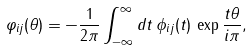<formula> <loc_0><loc_0><loc_500><loc_500>\varphi _ { i j } ( \theta ) = - \frac { 1 } { 2 \pi } \int _ { - \infty } ^ { \infty } d t \, \phi _ { i j } ( t ) \, \exp \frac { t \theta } { i \pi } ,</formula> 